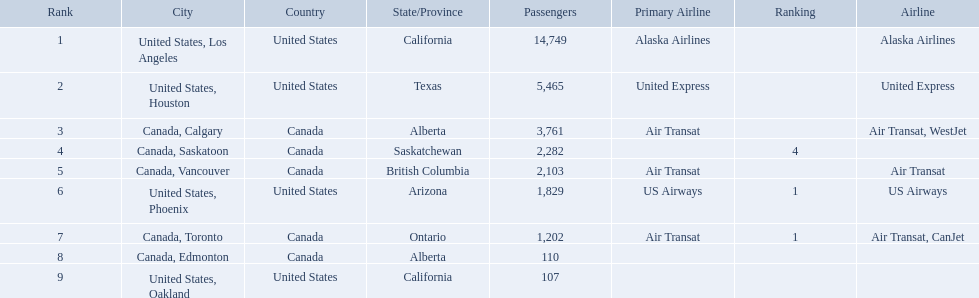What are all the cities? United States, Los Angeles, United States, Houston, Canada, Calgary, Canada, Saskatoon, Canada, Vancouver, United States, Phoenix, Canada, Toronto, Canada, Edmonton, United States, Oakland. How many passengers do they service? 14,749, 5,465, 3,761, 2,282, 2,103, 1,829, 1,202, 110, 107. Which city, when combined with los angeles, totals nearly 19,000? Canada, Calgary. What are the cities that are associated with the playa de oro international airport? United States, Los Angeles, United States, Houston, Canada, Calgary, Canada, Saskatoon, Canada, Vancouver, United States, Phoenix, Canada, Toronto, Canada, Edmonton, United States, Oakland. What is uniteed states, los angeles passenger count? 14,749. What other cities passenger count would lead to 19,000 roughly when combined with previous los angeles? Canada, Calgary. 